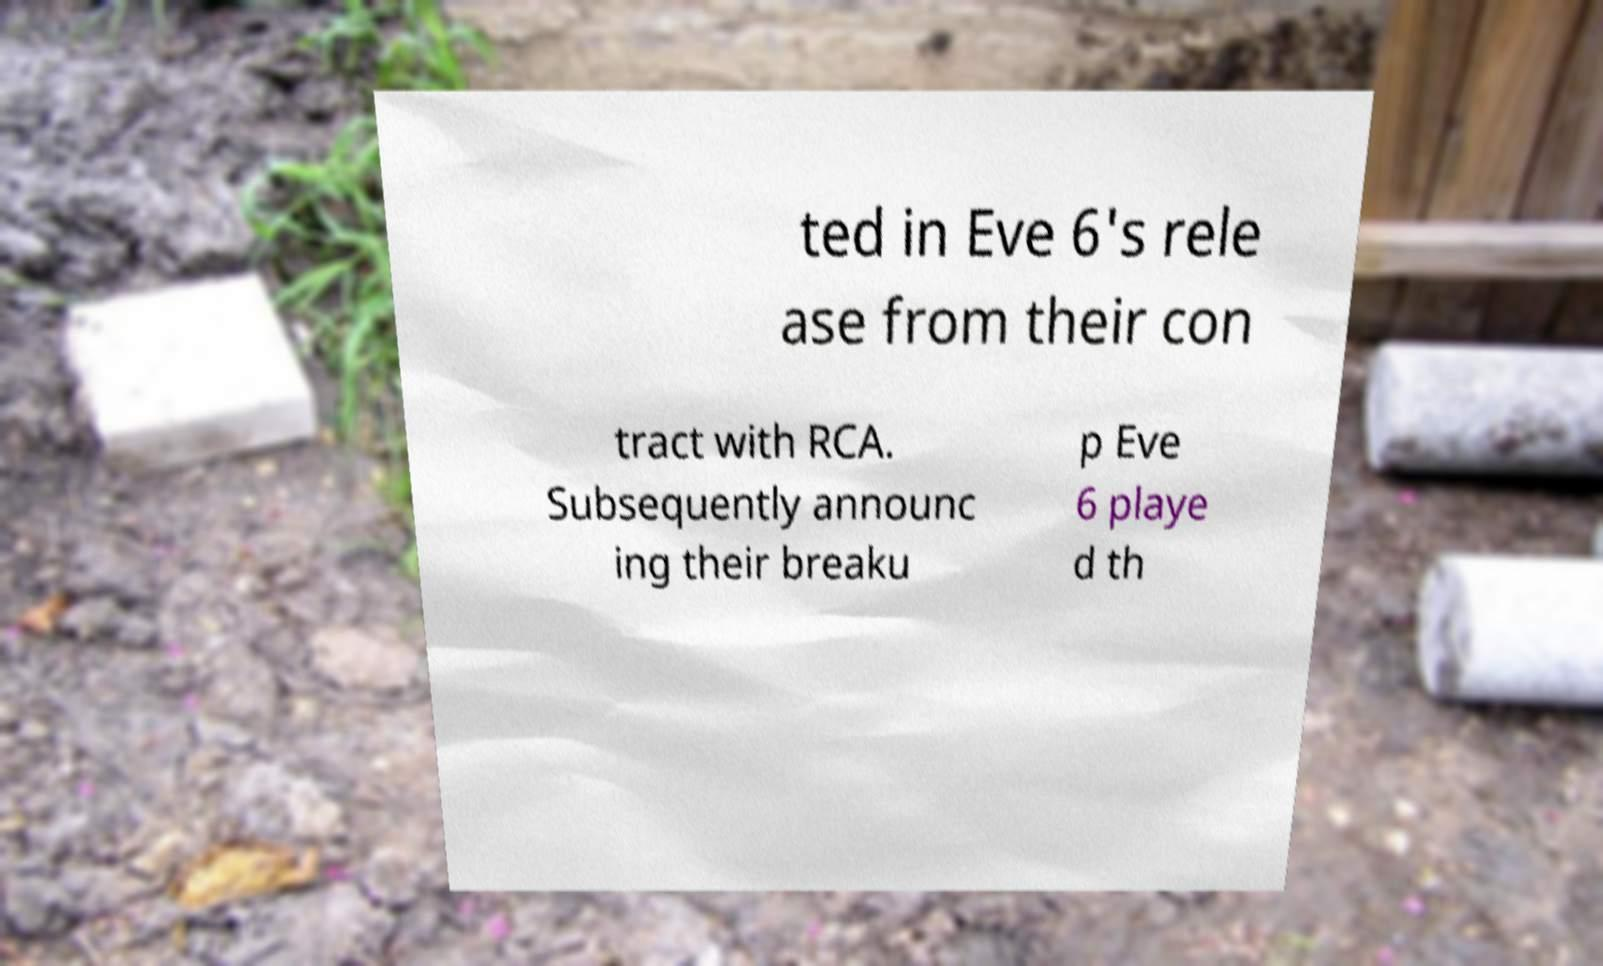I need the written content from this picture converted into text. Can you do that? ted in Eve 6's rele ase from their con tract with RCA. Subsequently announc ing their breaku p Eve 6 playe d th 